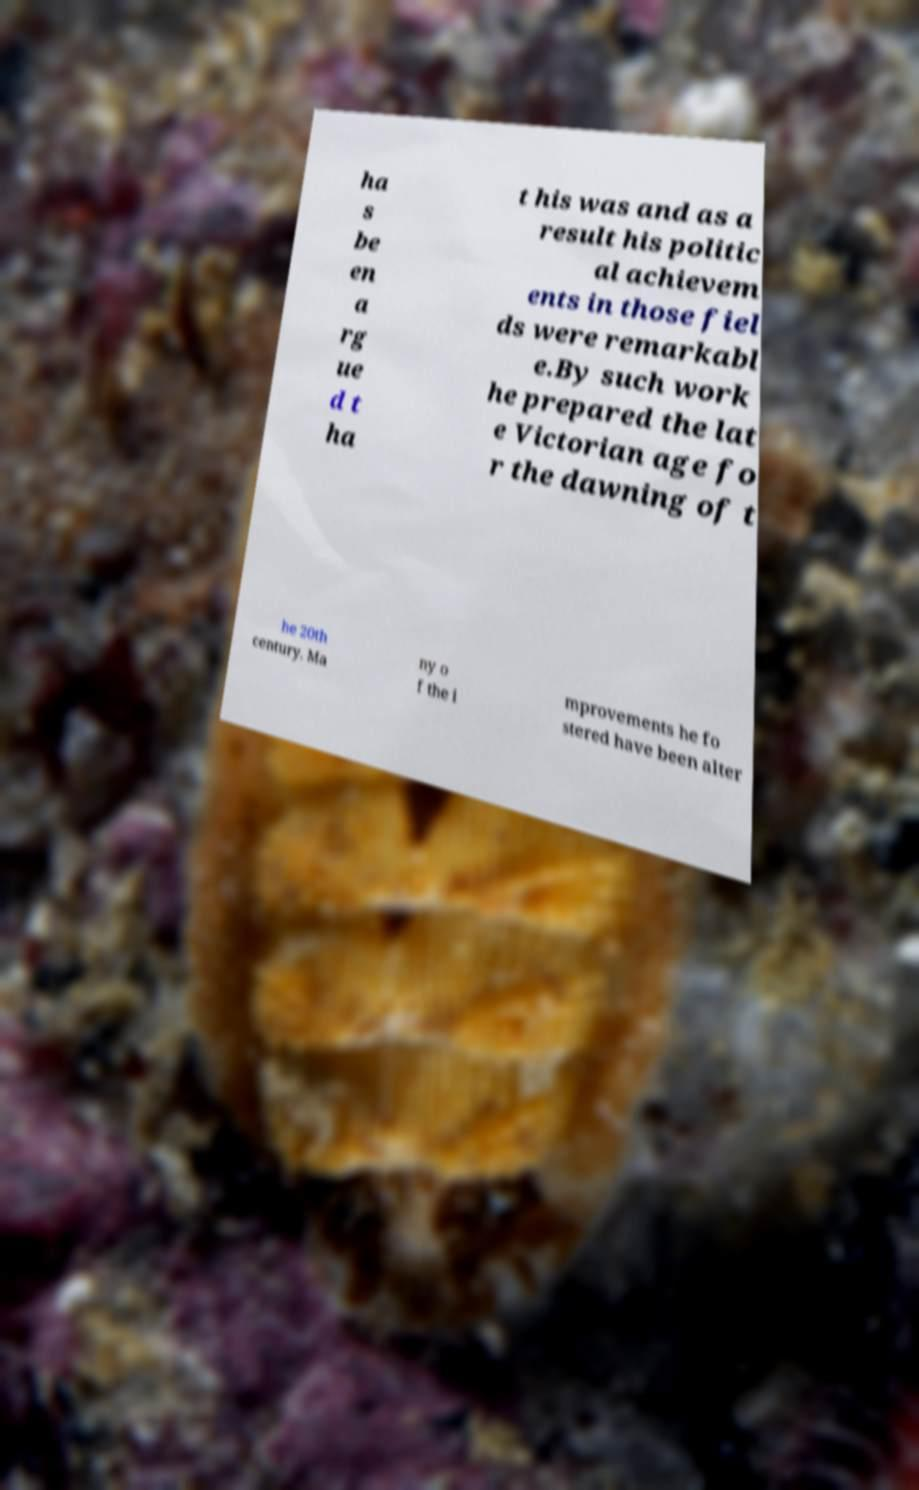For documentation purposes, I need the text within this image transcribed. Could you provide that? ha s be en a rg ue d t ha t his was and as a result his politic al achievem ents in those fiel ds were remarkabl e.By such work he prepared the lat e Victorian age fo r the dawning of t he 20th century. Ma ny o f the i mprovements he fo stered have been alter 